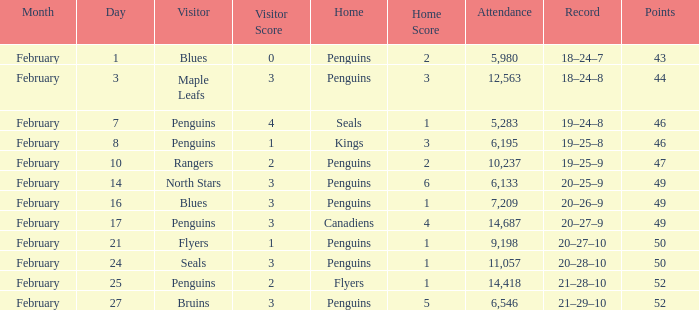What is the track record for a 2-1 outcome? 21–28–10. 